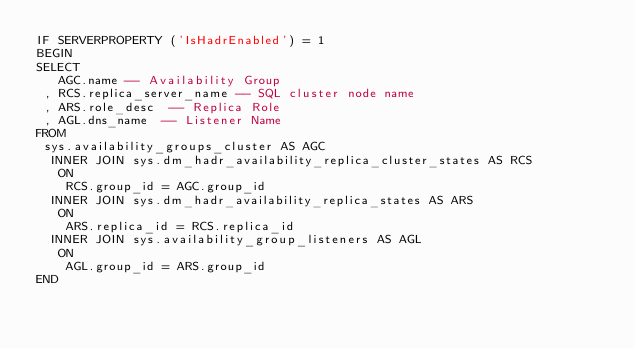<code> <loc_0><loc_0><loc_500><loc_500><_SQL_>IF SERVERPROPERTY ('IsHadrEnabled') = 1
BEGIN
SELECT
   AGC.name -- Availability Group
 , RCS.replica_server_name -- SQL cluster node name
 , ARS.role_desc  -- Replica Role
 , AGL.dns_name  -- Listener Name
FROM
 sys.availability_groups_cluster AS AGC
  INNER JOIN sys.dm_hadr_availability_replica_cluster_states AS RCS
   ON
    RCS.group_id = AGC.group_id
  INNER JOIN sys.dm_hadr_availability_replica_states AS ARS
   ON
    ARS.replica_id = RCS.replica_id
  INNER JOIN sys.availability_group_listeners AS AGL
   ON
    AGL.group_id = ARS.group_id
END</code> 